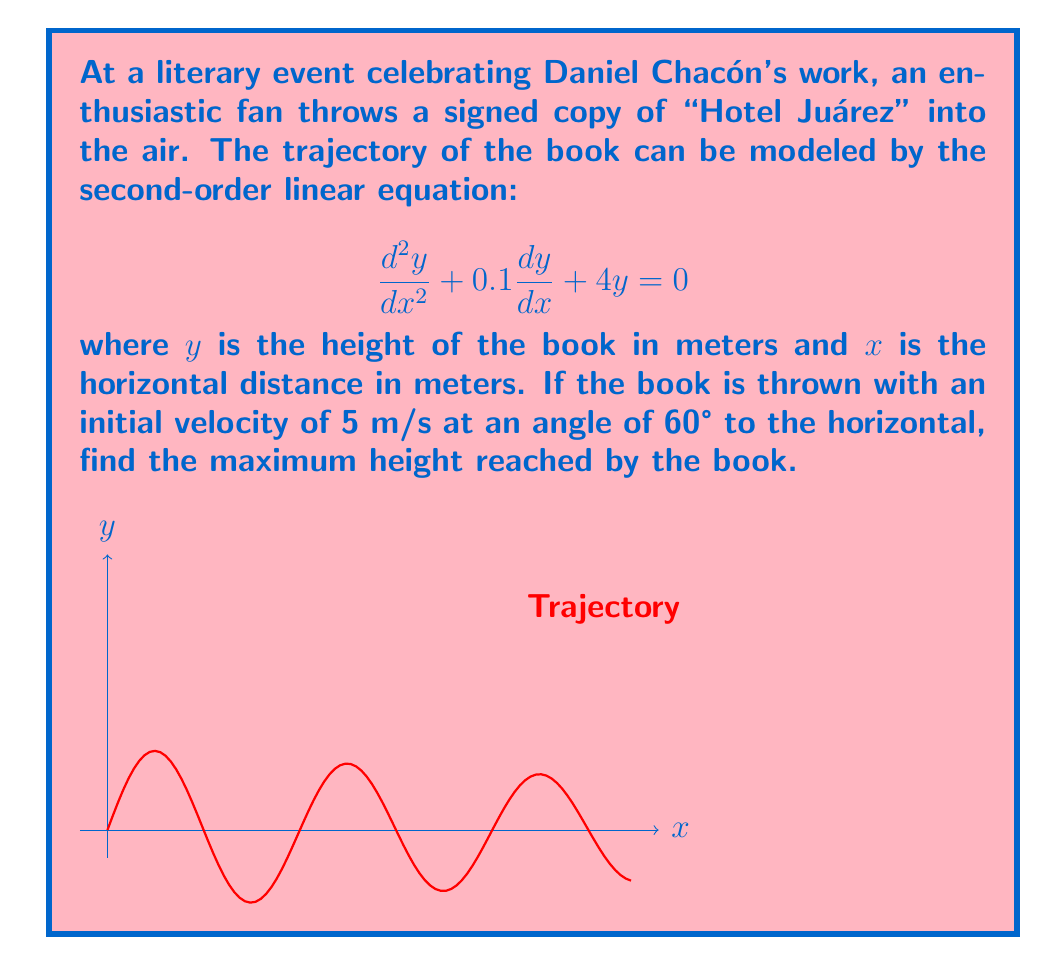Could you help me with this problem? Let's approach this step-by-step:

1) The general solution for this second-order linear equation is:
   $$y = e^{-0.05x}(A\cos(1.998x) + B\sin(1.998x))$$

2) We need to find A and B using initial conditions. At x = 0:
   $y(0) = A = 0$ (the book starts at ground level)
   $y'(0) = -0.05A + 1.998B = 5\sin(60°) = 4.33$

3) Solving for B:
   $1.998B = 4.33$
   $B = 2.17$

4) So our particular solution is:
   $$y = 2.17e^{-0.05x}\sin(1.998x)$$

5) To find the maximum height, we need to find where $\frac{dy}{dx} = 0$:
   $$\frac{dy}{dx} = 2.17e^{-0.05x}(-0.05\sin(1.998x) + 1.998\cos(1.998x)) = 0$$

6) This occurs when $\tan(1.998x) = 39.96$, or when $x ≈ 0.785$ meters.

7) Plugging this back into our solution:
   $$y_{max} = 2.17e^{-0.05(0.785)}\sin(1.998(0.785)) ≈ 1.86$$

Therefore, the maximum height reached by the book is approximately 1.86 meters.
Answer: 1.86 meters 